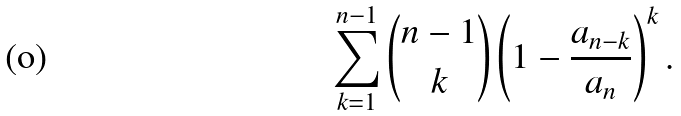Convert formula to latex. <formula><loc_0><loc_0><loc_500><loc_500>\sum _ { k = 1 } ^ { n - 1 } \binom { n - 1 } { k } \left ( 1 - \frac { a _ { n - k } } { a _ { n } } \right ) ^ { k } .</formula> 